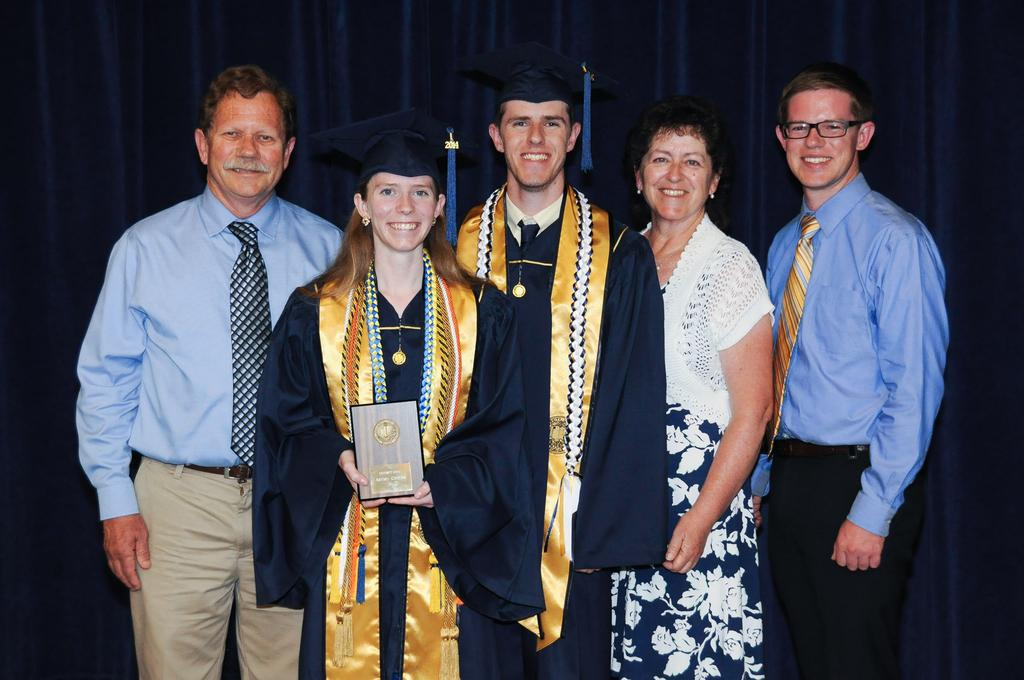How many people are present in the image? There are five people standing in the image. What is the facial expression of the people in the image? The people are smiling. What is the woman holding in the image? The woman is holding a shield with her hands. What can be seen in the background of the image? There are curtains in the background of the image. What is the price of the canvas in the image? There is no canvas present in the image, so it is not possible to determine its price. 